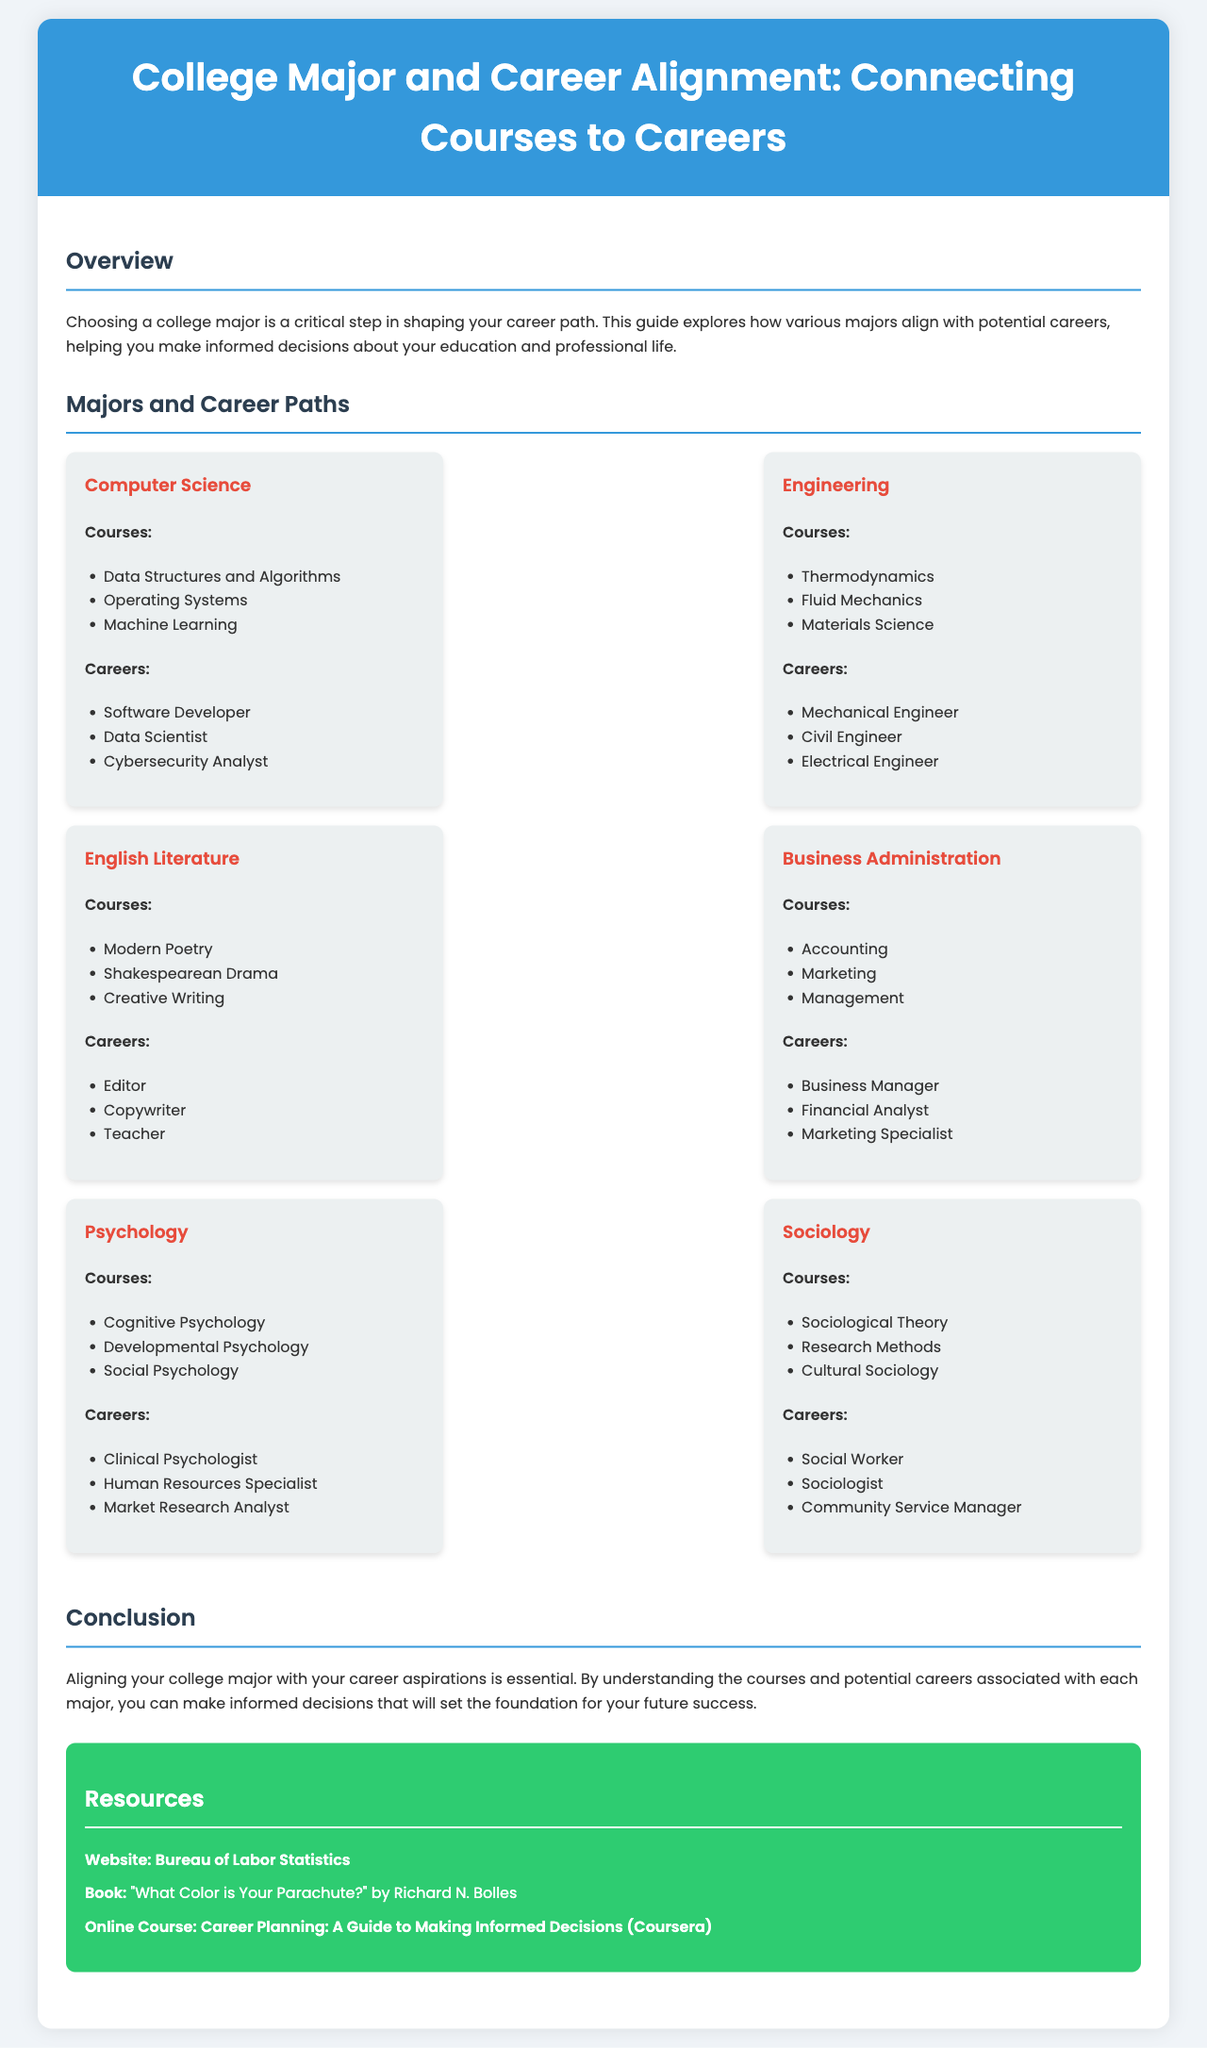What is the title of the document? The title of the document is presented in the header section and summarizes the main theme of the infographic.
Answer: College Major and Career Alignment: Connecting Courses to Careers How many majors are discussed in the document? The number of majors is determined by the specific entries listed under the "Majors and Career Paths" section of the document.
Answer: Six What is one career associated with the Psychology major? This question looks for a specific example of a career mentioned under the Psychology major section.
Answer: Clinical Psychologist Which course is listed under the Computer Science major? This question asks for a specific course that is part of the Computer Science major.
Answer: Data Structures and Algorithms Which major includes the course "Thermodynamics"? This question requires the reader to identify the major related to a specific course.
Answer: Engineering What color is the resources section background? The background color for the resources section is explicitly described in the document.
Answer: Green What is one recommended resource for career planning? This question asks for a tangible resource mentioned in the "Resources" section of the document.
Answer: Bureau of Labor Statistics How many careers are listed under Business Administration? This question aims to find out the number of career options provided under the Business Administration section.
Answer: Three What type of infographic is this document categorized as? This question inquires about the classification of the document's format.
Answer: Hierarchical infographic 